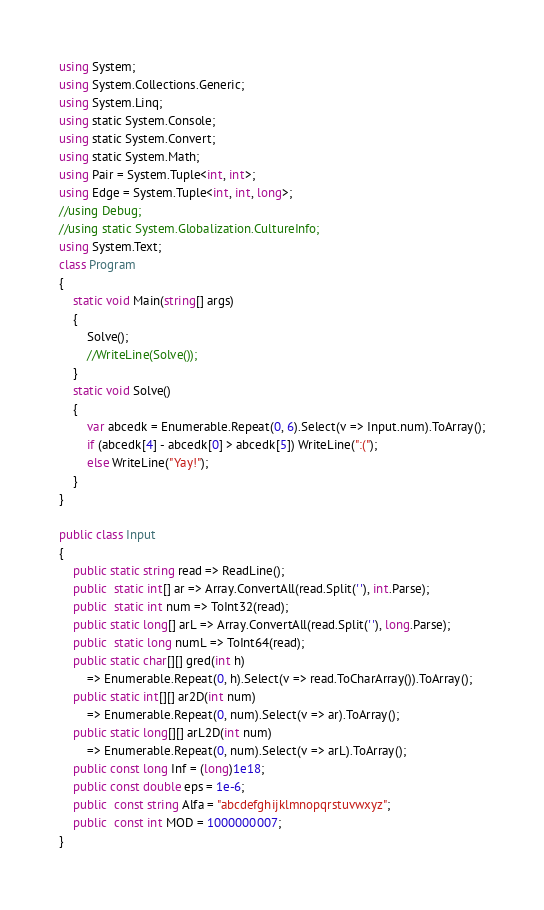<code> <loc_0><loc_0><loc_500><loc_500><_C#_>using System;
using System.Collections.Generic;
using System.Linq;
using static System.Console;
using static System.Convert;
using static System.Math;
using Pair = System.Tuple<int, int>;
using Edge = System.Tuple<int, int, long>;
//using Debug;
//using static System.Globalization.CultureInfo;
using System.Text;
class Program
{
    static void Main(string[] args)
    {
        Solve();
        //WriteLine(Solve());
    }
    static void Solve()
    {
        var abcedk = Enumerable.Repeat(0, 6).Select(v => Input.num).ToArray();
        if (abcedk[4] - abcedk[0] > abcedk[5]) WriteLine(":(");
        else WriteLine("Yay!");
    }
}

public class Input
{
    public static string read => ReadLine();
    public  static int[] ar => Array.ConvertAll(read.Split(' '), int.Parse);
    public  static int num => ToInt32(read);
    public static long[] arL => Array.ConvertAll(read.Split(' '), long.Parse);
    public  static long numL => ToInt64(read);
    public static char[][] gred(int h) 
        => Enumerable.Repeat(0, h).Select(v => read.ToCharArray()).ToArray();
    public static int[][] ar2D(int num)
        => Enumerable.Repeat(0, num).Select(v => ar).ToArray();
    public static long[][] arL2D(int num)
        => Enumerable.Repeat(0, num).Select(v => arL).ToArray();
    public const long Inf = (long)1e18;
    public const double eps = 1e-6;
    public  const string Alfa = "abcdefghijklmnopqrstuvwxyz";
    public  const int MOD = 1000000007;
}
</code> 